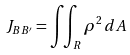<formula> <loc_0><loc_0><loc_500><loc_500>J _ { B B ^ { \prime } } = \iint _ { R } { \rho } ^ { 2 } \, d A</formula> 